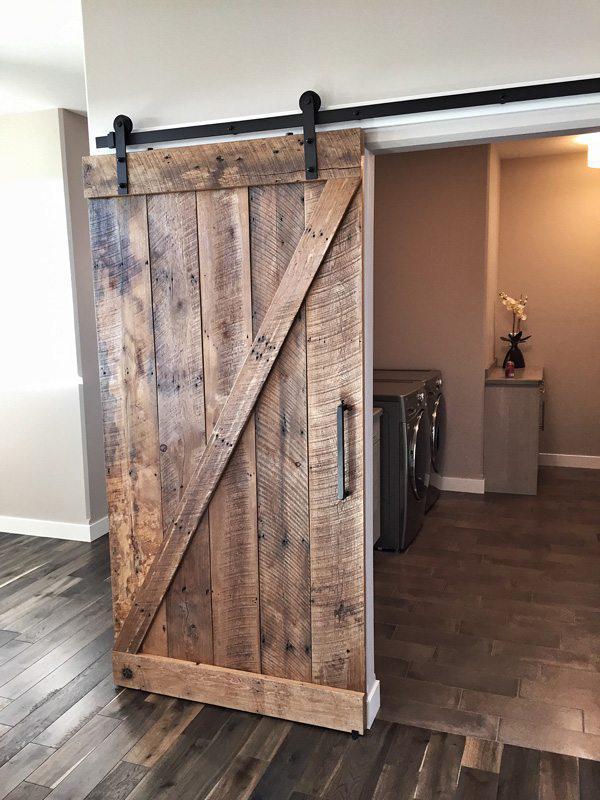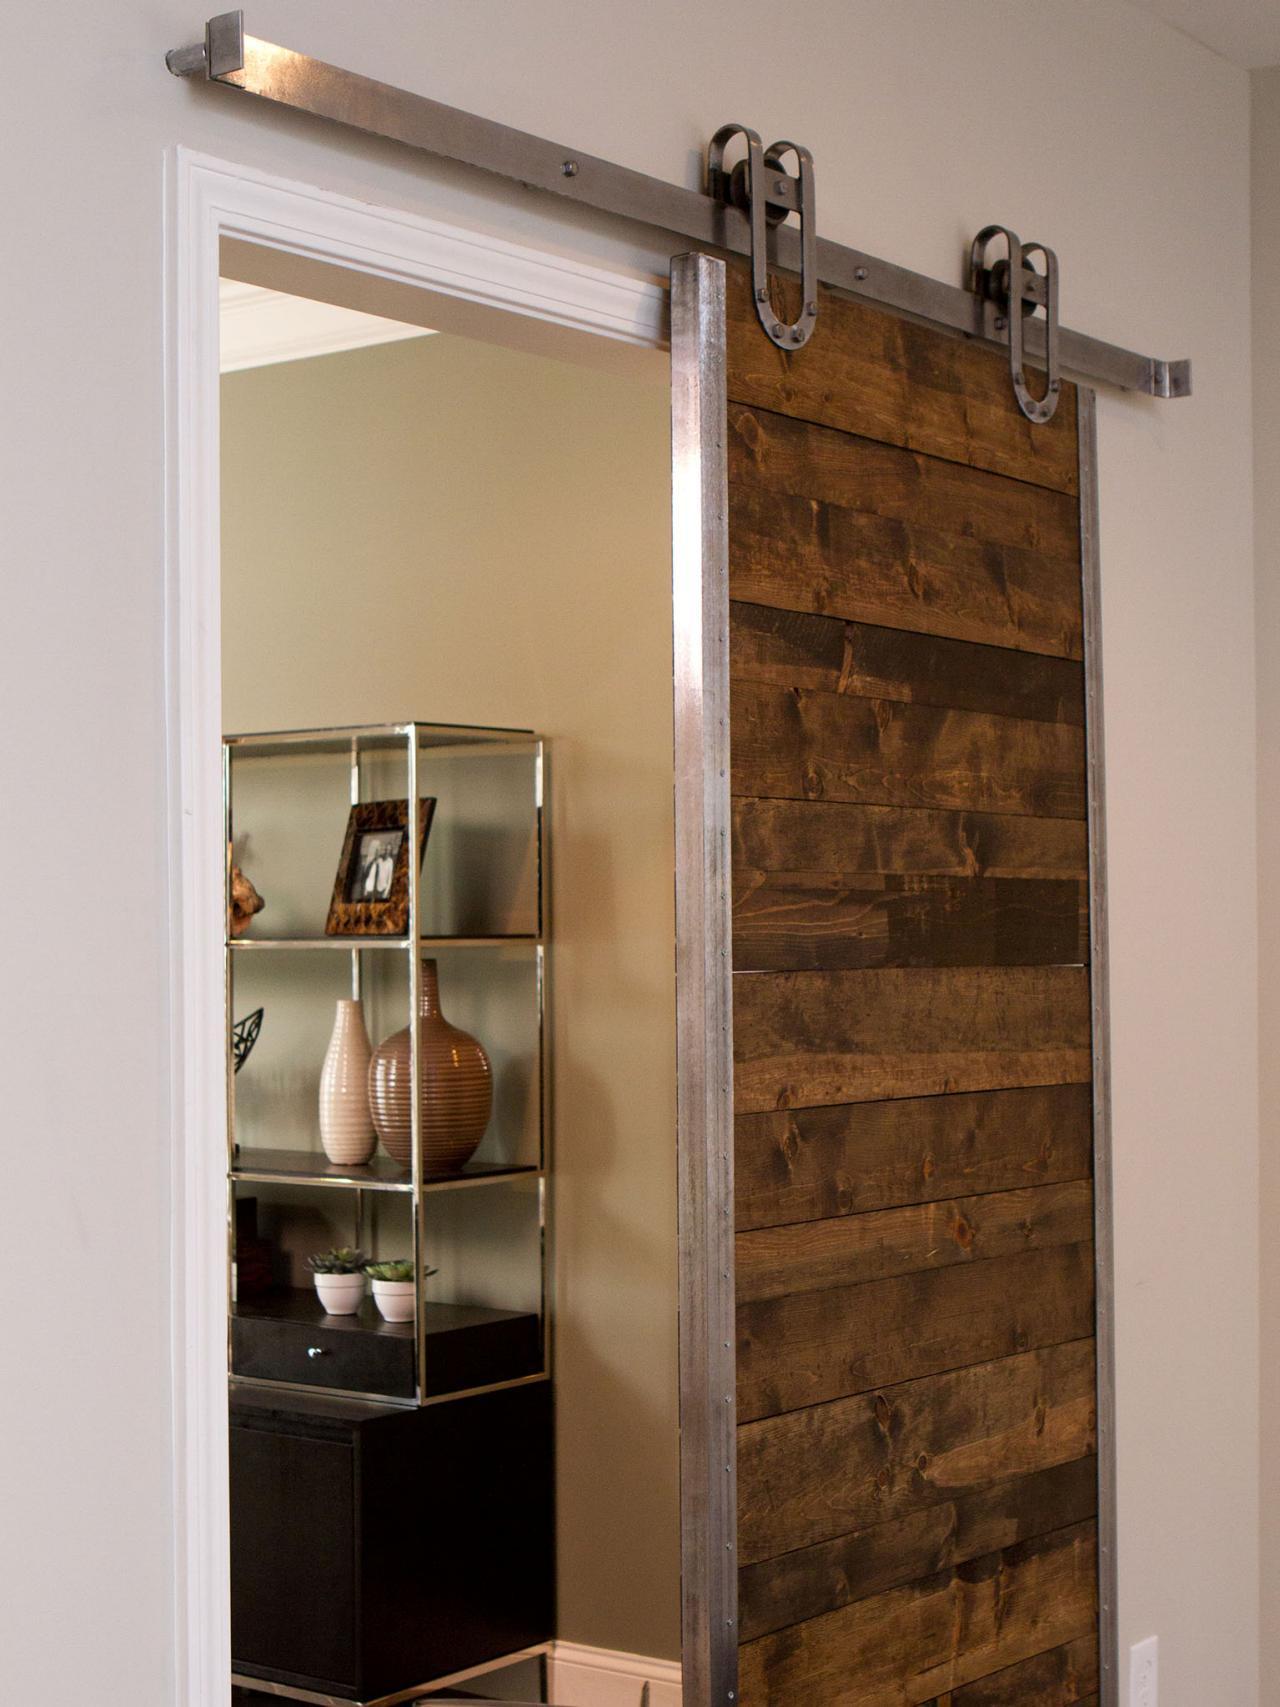The first image is the image on the left, the second image is the image on the right. Analyze the images presented: Is the assertion "All the sliding doors are solid wood." valid? Answer yes or no. Yes. The first image is the image on the left, the second image is the image on the right. Assess this claim about the two images: "There are three hanging doors.". Correct or not? Answer yes or no. No. 